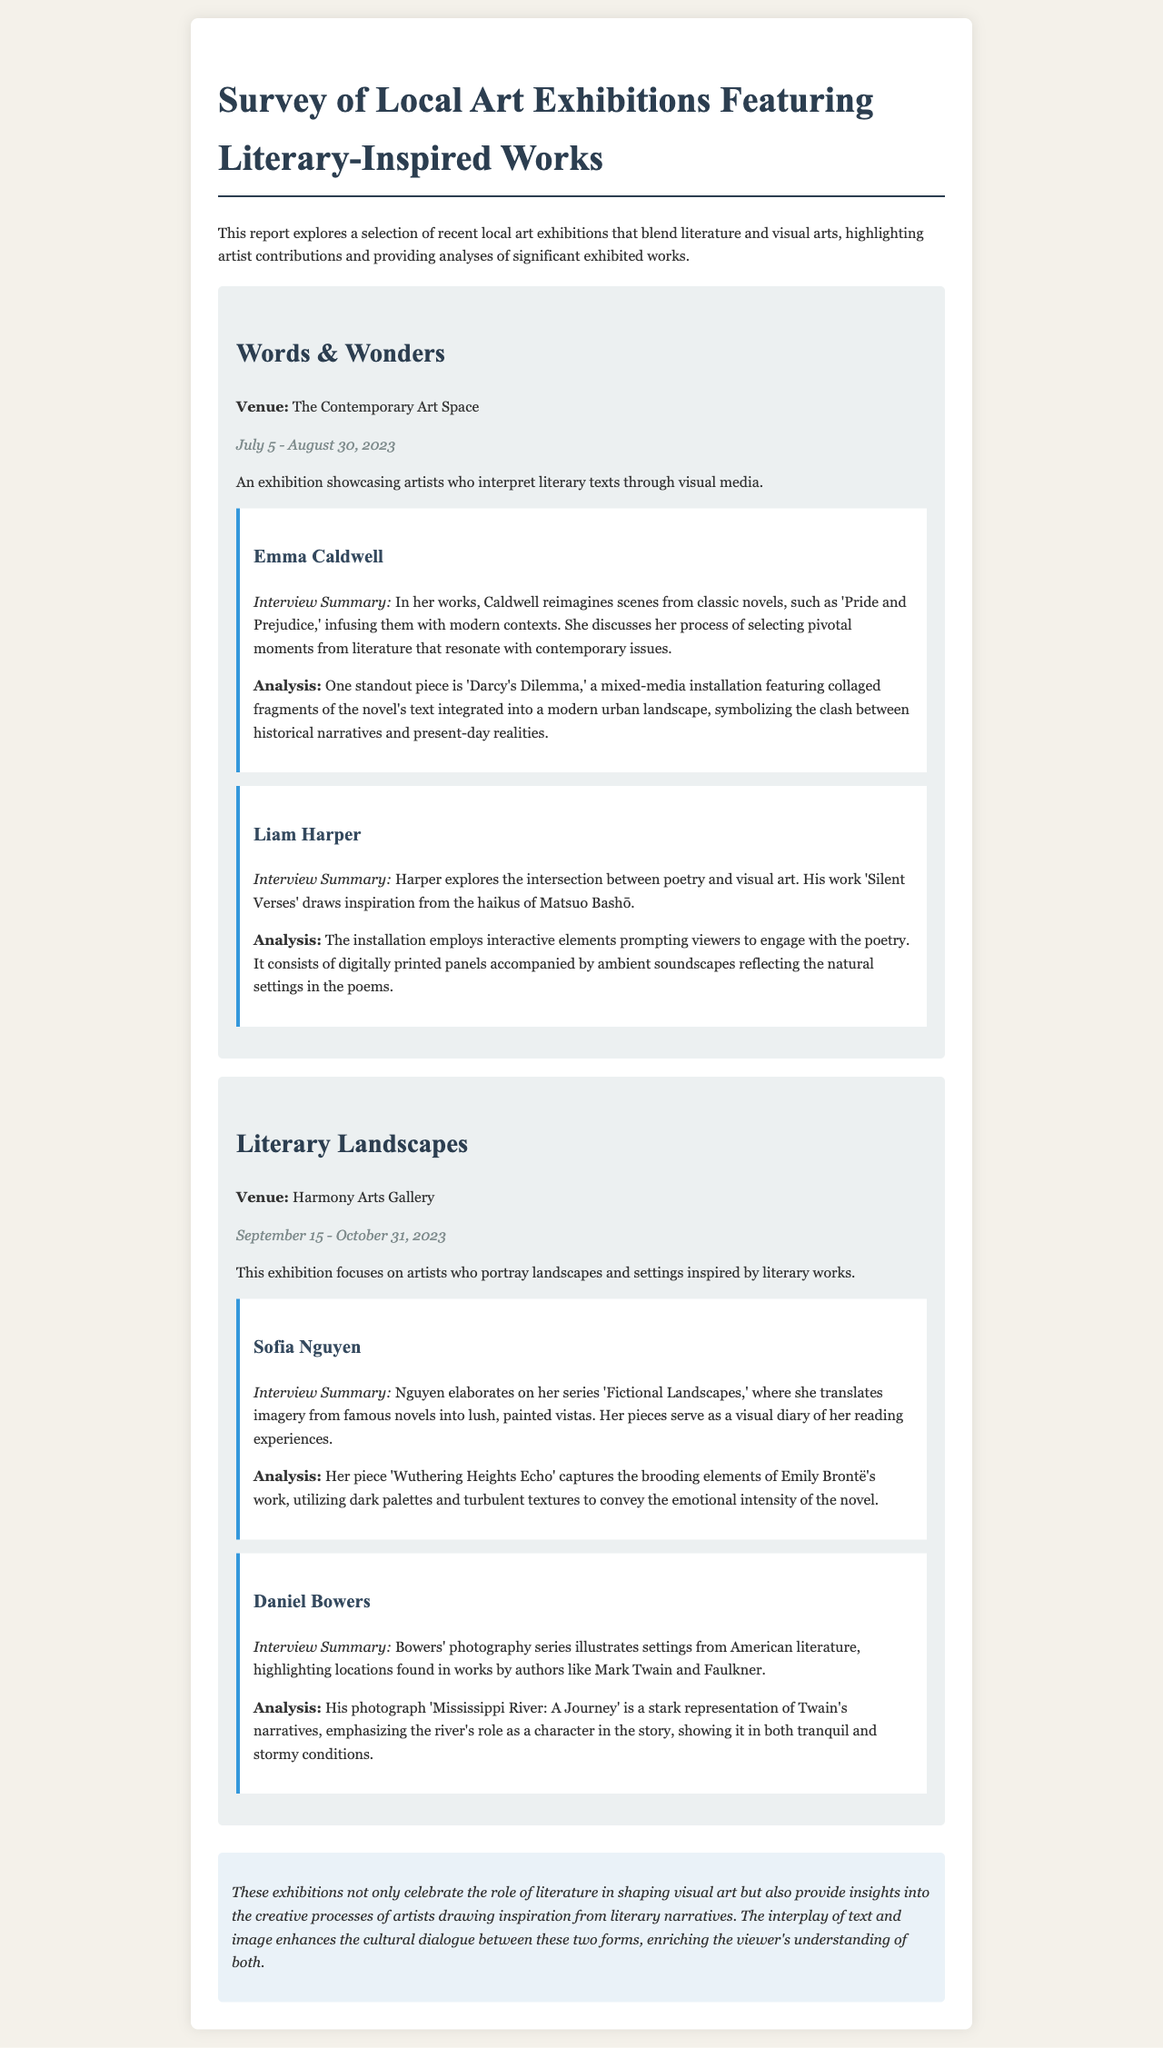What is the title of the report? The title is found at the top of the document and summarizes the content regarding local art exhibitions and literary-inspired works.
Answer: Survey of Local Art Exhibitions Featuring Literary-Inspired Works What are the dates for the exhibition "Words & Wonders"? The exhibition dates are provided in the overview of the first exhibition and specify when it takes place.
Answer: July 5 - August 30, 2023 Who is the artist featured in the piece "Darcy's Dilemma"? The analysis section of the first exhibition mentions this artist specifically in relation to the highlighted piece.
Answer: Emma Caldwell What is the main theme of the exhibition "Literary Landscapes"? The introduction of the second exhibition describes what the artists focus on, clarifying the overall concept of the event.
Answer: Landscapes and settings inspired by literary works Which artwork is associated with Sofia Nguyen? The analysis section mentions the specific piece she created that reflects her artistic approach and literary inspiration.
Answer: Wuthering Heights Echo How does Liam Harper's installation engage viewers? His interview summary provides insights into the interactive elements that are intended to create a connection with the audience.
Answer: Employs interactive elements What emotion does the color palette in Nguyen's artwork evoke? The analysis describes the use of color and texture in Nguyen's painting to convey a certain feeling related to the literary work it represents.
Answer: Brooding What is the conclusion about the relationship between literature and visual art? The conclusion section summarizes the main insights drawn from the survey, highlighting the interplay between the two forms of art.
Answer: Enhances the cultural dialogue How many featured artists are there in the exhibition "Words & Wonders"? By counting the artist profiles present in the first exhibition section, we can determine this number.
Answer: Two 